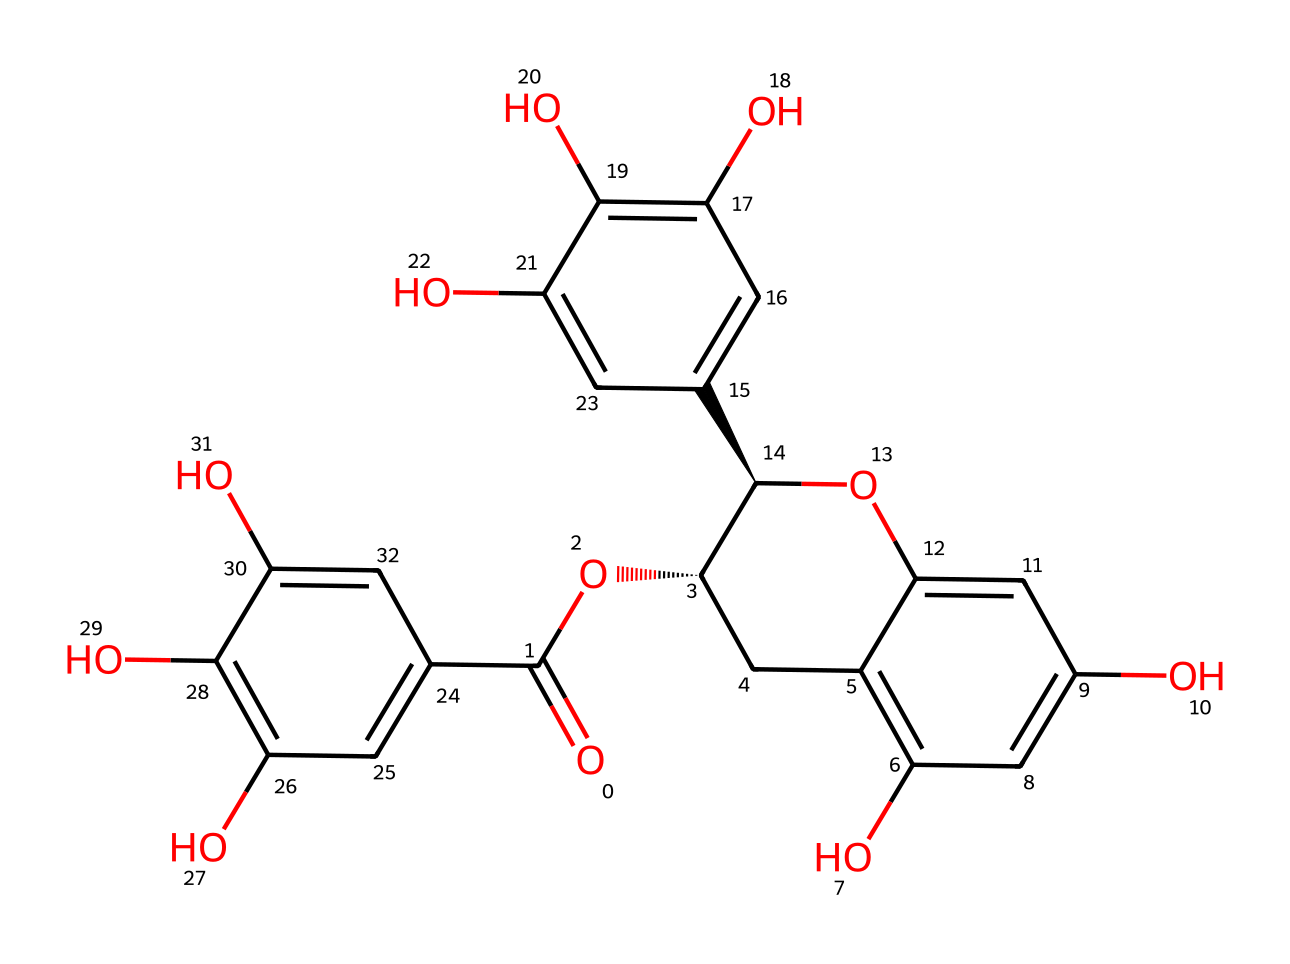What is the total number of carbon atoms in this compound? By examining the provided SMILES representation, we can count the number of carbon atoms. Each lowercase 'c' represents a carbon atom that is part of an aromatic ring. The 'C' refers to aliphatic carbon atoms. In total, there are 21 carbon atoms present in the structure.
Answer: 21 How many hydroxyl (–OH) groups are present in the structure? The hydroxyl groups are indicated by the 'O' in the structure connected to 'H'. By counting the 'O's connected to 'c' in the structure, we find that there are 6 hydroxyl groups present.
Answer: 6 What type of chemical is represented by this SMILES structure? The compound is a polyphenol due to the presence of multiple phenolic hydroxyl groups in its structure. Polyphenols are characterized by having multiple phenolic units.
Answer: polyphenol Which functional group is responsible for the acidity of this compound? The presence of a carboxylic acid functional group (–COOH) is evident from the 'O=C(O' portion of the SMILES. This group contributes to the acidic properties of the compound.
Answer: carboxylic acid How many rings are present in the structure? By analyzing the cyclic structures formed by the carbon atoms in the SMILES representation, we identify that there are 4 aromatic rings in this chemical.
Answer: 4 What is the stereochemistry at the chiral centers? The '@' symbols in the SMILES indicate the presence of chiral centers. There are two chiral centers, denoting specific three-dimensional configurations.
Answer: 2 chiral centers 